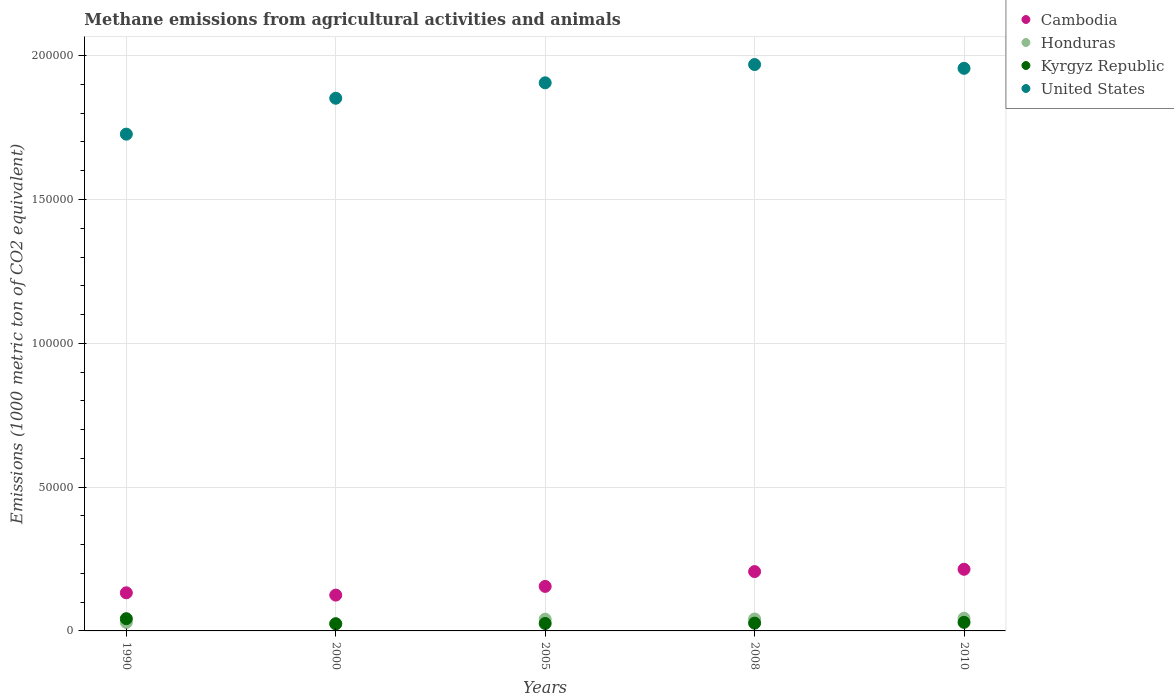How many different coloured dotlines are there?
Your answer should be compact. 4. Is the number of dotlines equal to the number of legend labels?
Your response must be concise. Yes. What is the amount of methane emitted in Honduras in 2010?
Your answer should be very brief. 4399.5. Across all years, what is the maximum amount of methane emitted in Honduras?
Your answer should be very brief. 4399.5. Across all years, what is the minimum amount of methane emitted in Kyrgyz Republic?
Provide a succinct answer. 2487.9. In which year was the amount of methane emitted in Honduras maximum?
Provide a short and direct response. 2010. In which year was the amount of methane emitted in Kyrgyz Republic minimum?
Keep it short and to the point. 2000. What is the total amount of methane emitted in Kyrgyz Republic in the graph?
Offer a very short reply. 1.50e+04. What is the difference between the amount of methane emitted in United States in 1990 and that in 2005?
Give a very brief answer. -1.78e+04. What is the difference between the amount of methane emitted in Kyrgyz Republic in 2000 and the amount of methane emitted in Honduras in 2008?
Your response must be concise. -1661.4. What is the average amount of methane emitted in United States per year?
Give a very brief answer. 1.88e+05. In the year 2005, what is the difference between the amount of methane emitted in Cambodia and amount of methane emitted in United States?
Provide a short and direct response. -1.75e+05. What is the ratio of the amount of methane emitted in United States in 1990 to that in 2005?
Ensure brevity in your answer.  0.91. What is the difference between the highest and the second highest amount of methane emitted in Kyrgyz Republic?
Your response must be concise. 1275.7. What is the difference between the highest and the lowest amount of methane emitted in Kyrgyz Republic?
Your answer should be very brief. 1766.7. In how many years, is the amount of methane emitted in Cambodia greater than the average amount of methane emitted in Cambodia taken over all years?
Offer a terse response. 2. Is it the case that in every year, the sum of the amount of methane emitted in Kyrgyz Republic and amount of methane emitted in Cambodia  is greater than the sum of amount of methane emitted in Honduras and amount of methane emitted in United States?
Your response must be concise. No. Is the amount of methane emitted in Kyrgyz Republic strictly greater than the amount of methane emitted in United States over the years?
Your answer should be compact. No. Is the amount of methane emitted in Cambodia strictly less than the amount of methane emitted in Honduras over the years?
Give a very brief answer. No. What is the difference between two consecutive major ticks on the Y-axis?
Offer a terse response. 5.00e+04. Are the values on the major ticks of Y-axis written in scientific E-notation?
Keep it short and to the point. No. Does the graph contain any zero values?
Your answer should be very brief. No. How are the legend labels stacked?
Give a very brief answer. Vertical. What is the title of the graph?
Give a very brief answer. Methane emissions from agricultural activities and animals. Does "Cabo Verde" appear as one of the legend labels in the graph?
Give a very brief answer. No. What is the label or title of the X-axis?
Your response must be concise. Years. What is the label or title of the Y-axis?
Ensure brevity in your answer.  Emissions (1000 metric ton of CO2 equivalent). What is the Emissions (1000 metric ton of CO2 equivalent) of Cambodia in 1990?
Offer a very short reply. 1.32e+04. What is the Emissions (1000 metric ton of CO2 equivalent) of Honduras in 1990?
Your answer should be compact. 2946.5. What is the Emissions (1000 metric ton of CO2 equivalent) of Kyrgyz Republic in 1990?
Give a very brief answer. 4254.6. What is the Emissions (1000 metric ton of CO2 equivalent) of United States in 1990?
Provide a succinct answer. 1.73e+05. What is the Emissions (1000 metric ton of CO2 equivalent) in Cambodia in 2000?
Offer a very short reply. 1.25e+04. What is the Emissions (1000 metric ton of CO2 equivalent) of Honduras in 2000?
Keep it short and to the point. 2470.9. What is the Emissions (1000 metric ton of CO2 equivalent) in Kyrgyz Republic in 2000?
Provide a succinct answer. 2487.9. What is the Emissions (1000 metric ton of CO2 equivalent) in United States in 2000?
Keep it short and to the point. 1.85e+05. What is the Emissions (1000 metric ton of CO2 equivalent) of Cambodia in 2005?
Provide a succinct answer. 1.55e+04. What is the Emissions (1000 metric ton of CO2 equivalent) in Honduras in 2005?
Provide a short and direct response. 4084.8. What is the Emissions (1000 metric ton of CO2 equivalent) of Kyrgyz Republic in 2005?
Offer a very short reply. 2595. What is the Emissions (1000 metric ton of CO2 equivalent) of United States in 2005?
Make the answer very short. 1.91e+05. What is the Emissions (1000 metric ton of CO2 equivalent) in Cambodia in 2008?
Provide a short and direct response. 2.06e+04. What is the Emissions (1000 metric ton of CO2 equivalent) in Honduras in 2008?
Your response must be concise. 4149.3. What is the Emissions (1000 metric ton of CO2 equivalent) of Kyrgyz Republic in 2008?
Provide a succinct answer. 2707.7. What is the Emissions (1000 metric ton of CO2 equivalent) in United States in 2008?
Your answer should be compact. 1.97e+05. What is the Emissions (1000 metric ton of CO2 equivalent) of Cambodia in 2010?
Your response must be concise. 2.14e+04. What is the Emissions (1000 metric ton of CO2 equivalent) in Honduras in 2010?
Ensure brevity in your answer.  4399.5. What is the Emissions (1000 metric ton of CO2 equivalent) in Kyrgyz Republic in 2010?
Offer a very short reply. 2978.9. What is the Emissions (1000 metric ton of CO2 equivalent) of United States in 2010?
Offer a terse response. 1.96e+05. Across all years, what is the maximum Emissions (1000 metric ton of CO2 equivalent) in Cambodia?
Your response must be concise. 2.14e+04. Across all years, what is the maximum Emissions (1000 metric ton of CO2 equivalent) in Honduras?
Give a very brief answer. 4399.5. Across all years, what is the maximum Emissions (1000 metric ton of CO2 equivalent) of Kyrgyz Republic?
Offer a very short reply. 4254.6. Across all years, what is the maximum Emissions (1000 metric ton of CO2 equivalent) of United States?
Give a very brief answer. 1.97e+05. Across all years, what is the minimum Emissions (1000 metric ton of CO2 equivalent) of Cambodia?
Ensure brevity in your answer.  1.25e+04. Across all years, what is the minimum Emissions (1000 metric ton of CO2 equivalent) of Honduras?
Keep it short and to the point. 2470.9. Across all years, what is the minimum Emissions (1000 metric ton of CO2 equivalent) of Kyrgyz Republic?
Keep it short and to the point. 2487.9. Across all years, what is the minimum Emissions (1000 metric ton of CO2 equivalent) of United States?
Your answer should be compact. 1.73e+05. What is the total Emissions (1000 metric ton of CO2 equivalent) in Cambodia in the graph?
Provide a succinct answer. 8.32e+04. What is the total Emissions (1000 metric ton of CO2 equivalent) in Honduras in the graph?
Ensure brevity in your answer.  1.81e+04. What is the total Emissions (1000 metric ton of CO2 equivalent) in Kyrgyz Republic in the graph?
Offer a very short reply. 1.50e+04. What is the total Emissions (1000 metric ton of CO2 equivalent) of United States in the graph?
Offer a very short reply. 9.41e+05. What is the difference between the Emissions (1000 metric ton of CO2 equivalent) of Cambodia in 1990 and that in 2000?
Provide a succinct answer. 796.5. What is the difference between the Emissions (1000 metric ton of CO2 equivalent) in Honduras in 1990 and that in 2000?
Your answer should be compact. 475.6. What is the difference between the Emissions (1000 metric ton of CO2 equivalent) in Kyrgyz Republic in 1990 and that in 2000?
Your response must be concise. 1766.7. What is the difference between the Emissions (1000 metric ton of CO2 equivalent) in United States in 1990 and that in 2000?
Your answer should be very brief. -1.25e+04. What is the difference between the Emissions (1000 metric ton of CO2 equivalent) of Cambodia in 1990 and that in 2005?
Your answer should be compact. -2227.1. What is the difference between the Emissions (1000 metric ton of CO2 equivalent) of Honduras in 1990 and that in 2005?
Ensure brevity in your answer.  -1138.3. What is the difference between the Emissions (1000 metric ton of CO2 equivalent) of Kyrgyz Republic in 1990 and that in 2005?
Make the answer very short. 1659.6. What is the difference between the Emissions (1000 metric ton of CO2 equivalent) in United States in 1990 and that in 2005?
Your answer should be very brief. -1.78e+04. What is the difference between the Emissions (1000 metric ton of CO2 equivalent) of Cambodia in 1990 and that in 2008?
Your answer should be very brief. -7382.4. What is the difference between the Emissions (1000 metric ton of CO2 equivalent) of Honduras in 1990 and that in 2008?
Ensure brevity in your answer.  -1202.8. What is the difference between the Emissions (1000 metric ton of CO2 equivalent) of Kyrgyz Republic in 1990 and that in 2008?
Provide a succinct answer. 1546.9. What is the difference between the Emissions (1000 metric ton of CO2 equivalent) in United States in 1990 and that in 2008?
Provide a short and direct response. -2.42e+04. What is the difference between the Emissions (1000 metric ton of CO2 equivalent) in Cambodia in 1990 and that in 2010?
Your response must be concise. -8182.5. What is the difference between the Emissions (1000 metric ton of CO2 equivalent) of Honduras in 1990 and that in 2010?
Offer a terse response. -1453. What is the difference between the Emissions (1000 metric ton of CO2 equivalent) of Kyrgyz Republic in 1990 and that in 2010?
Give a very brief answer. 1275.7. What is the difference between the Emissions (1000 metric ton of CO2 equivalent) in United States in 1990 and that in 2010?
Give a very brief answer. -2.29e+04. What is the difference between the Emissions (1000 metric ton of CO2 equivalent) in Cambodia in 2000 and that in 2005?
Offer a terse response. -3023.6. What is the difference between the Emissions (1000 metric ton of CO2 equivalent) of Honduras in 2000 and that in 2005?
Provide a succinct answer. -1613.9. What is the difference between the Emissions (1000 metric ton of CO2 equivalent) of Kyrgyz Republic in 2000 and that in 2005?
Your answer should be very brief. -107.1. What is the difference between the Emissions (1000 metric ton of CO2 equivalent) of United States in 2000 and that in 2005?
Your answer should be compact. -5362.7. What is the difference between the Emissions (1000 metric ton of CO2 equivalent) of Cambodia in 2000 and that in 2008?
Your answer should be very brief. -8178.9. What is the difference between the Emissions (1000 metric ton of CO2 equivalent) in Honduras in 2000 and that in 2008?
Offer a terse response. -1678.4. What is the difference between the Emissions (1000 metric ton of CO2 equivalent) of Kyrgyz Republic in 2000 and that in 2008?
Ensure brevity in your answer.  -219.8. What is the difference between the Emissions (1000 metric ton of CO2 equivalent) in United States in 2000 and that in 2008?
Your answer should be very brief. -1.17e+04. What is the difference between the Emissions (1000 metric ton of CO2 equivalent) of Cambodia in 2000 and that in 2010?
Ensure brevity in your answer.  -8979. What is the difference between the Emissions (1000 metric ton of CO2 equivalent) of Honduras in 2000 and that in 2010?
Keep it short and to the point. -1928.6. What is the difference between the Emissions (1000 metric ton of CO2 equivalent) in Kyrgyz Republic in 2000 and that in 2010?
Keep it short and to the point. -491. What is the difference between the Emissions (1000 metric ton of CO2 equivalent) of United States in 2000 and that in 2010?
Offer a terse response. -1.04e+04. What is the difference between the Emissions (1000 metric ton of CO2 equivalent) of Cambodia in 2005 and that in 2008?
Make the answer very short. -5155.3. What is the difference between the Emissions (1000 metric ton of CO2 equivalent) of Honduras in 2005 and that in 2008?
Give a very brief answer. -64.5. What is the difference between the Emissions (1000 metric ton of CO2 equivalent) in Kyrgyz Republic in 2005 and that in 2008?
Provide a succinct answer. -112.7. What is the difference between the Emissions (1000 metric ton of CO2 equivalent) of United States in 2005 and that in 2008?
Give a very brief answer. -6353.6. What is the difference between the Emissions (1000 metric ton of CO2 equivalent) of Cambodia in 2005 and that in 2010?
Offer a terse response. -5955.4. What is the difference between the Emissions (1000 metric ton of CO2 equivalent) in Honduras in 2005 and that in 2010?
Provide a short and direct response. -314.7. What is the difference between the Emissions (1000 metric ton of CO2 equivalent) in Kyrgyz Republic in 2005 and that in 2010?
Offer a very short reply. -383.9. What is the difference between the Emissions (1000 metric ton of CO2 equivalent) of United States in 2005 and that in 2010?
Provide a short and direct response. -5038.6. What is the difference between the Emissions (1000 metric ton of CO2 equivalent) of Cambodia in 2008 and that in 2010?
Give a very brief answer. -800.1. What is the difference between the Emissions (1000 metric ton of CO2 equivalent) of Honduras in 2008 and that in 2010?
Your response must be concise. -250.2. What is the difference between the Emissions (1000 metric ton of CO2 equivalent) in Kyrgyz Republic in 2008 and that in 2010?
Offer a very short reply. -271.2. What is the difference between the Emissions (1000 metric ton of CO2 equivalent) of United States in 2008 and that in 2010?
Offer a very short reply. 1315. What is the difference between the Emissions (1000 metric ton of CO2 equivalent) of Cambodia in 1990 and the Emissions (1000 metric ton of CO2 equivalent) of Honduras in 2000?
Provide a short and direct response. 1.08e+04. What is the difference between the Emissions (1000 metric ton of CO2 equivalent) in Cambodia in 1990 and the Emissions (1000 metric ton of CO2 equivalent) in Kyrgyz Republic in 2000?
Give a very brief answer. 1.08e+04. What is the difference between the Emissions (1000 metric ton of CO2 equivalent) in Cambodia in 1990 and the Emissions (1000 metric ton of CO2 equivalent) in United States in 2000?
Keep it short and to the point. -1.72e+05. What is the difference between the Emissions (1000 metric ton of CO2 equivalent) in Honduras in 1990 and the Emissions (1000 metric ton of CO2 equivalent) in Kyrgyz Republic in 2000?
Offer a very short reply. 458.6. What is the difference between the Emissions (1000 metric ton of CO2 equivalent) of Honduras in 1990 and the Emissions (1000 metric ton of CO2 equivalent) of United States in 2000?
Give a very brief answer. -1.82e+05. What is the difference between the Emissions (1000 metric ton of CO2 equivalent) in Kyrgyz Republic in 1990 and the Emissions (1000 metric ton of CO2 equivalent) in United States in 2000?
Offer a terse response. -1.81e+05. What is the difference between the Emissions (1000 metric ton of CO2 equivalent) of Cambodia in 1990 and the Emissions (1000 metric ton of CO2 equivalent) of Honduras in 2005?
Make the answer very short. 9165. What is the difference between the Emissions (1000 metric ton of CO2 equivalent) in Cambodia in 1990 and the Emissions (1000 metric ton of CO2 equivalent) in Kyrgyz Republic in 2005?
Your response must be concise. 1.07e+04. What is the difference between the Emissions (1000 metric ton of CO2 equivalent) of Cambodia in 1990 and the Emissions (1000 metric ton of CO2 equivalent) of United States in 2005?
Give a very brief answer. -1.77e+05. What is the difference between the Emissions (1000 metric ton of CO2 equivalent) in Honduras in 1990 and the Emissions (1000 metric ton of CO2 equivalent) in Kyrgyz Republic in 2005?
Your answer should be very brief. 351.5. What is the difference between the Emissions (1000 metric ton of CO2 equivalent) of Honduras in 1990 and the Emissions (1000 metric ton of CO2 equivalent) of United States in 2005?
Provide a short and direct response. -1.88e+05. What is the difference between the Emissions (1000 metric ton of CO2 equivalent) of Kyrgyz Republic in 1990 and the Emissions (1000 metric ton of CO2 equivalent) of United States in 2005?
Ensure brevity in your answer.  -1.86e+05. What is the difference between the Emissions (1000 metric ton of CO2 equivalent) in Cambodia in 1990 and the Emissions (1000 metric ton of CO2 equivalent) in Honduras in 2008?
Your response must be concise. 9100.5. What is the difference between the Emissions (1000 metric ton of CO2 equivalent) in Cambodia in 1990 and the Emissions (1000 metric ton of CO2 equivalent) in Kyrgyz Republic in 2008?
Offer a terse response. 1.05e+04. What is the difference between the Emissions (1000 metric ton of CO2 equivalent) in Cambodia in 1990 and the Emissions (1000 metric ton of CO2 equivalent) in United States in 2008?
Provide a succinct answer. -1.84e+05. What is the difference between the Emissions (1000 metric ton of CO2 equivalent) of Honduras in 1990 and the Emissions (1000 metric ton of CO2 equivalent) of Kyrgyz Republic in 2008?
Offer a terse response. 238.8. What is the difference between the Emissions (1000 metric ton of CO2 equivalent) of Honduras in 1990 and the Emissions (1000 metric ton of CO2 equivalent) of United States in 2008?
Provide a short and direct response. -1.94e+05. What is the difference between the Emissions (1000 metric ton of CO2 equivalent) in Kyrgyz Republic in 1990 and the Emissions (1000 metric ton of CO2 equivalent) in United States in 2008?
Keep it short and to the point. -1.93e+05. What is the difference between the Emissions (1000 metric ton of CO2 equivalent) in Cambodia in 1990 and the Emissions (1000 metric ton of CO2 equivalent) in Honduras in 2010?
Ensure brevity in your answer.  8850.3. What is the difference between the Emissions (1000 metric ton of CO2 equivalent) of Cambodia in 1990 and the Emissions (1000 metric ton of CO2 equivalent) of Kyrgyz Republic in 2010?
Ensure brevity in your answer.  1.03e+04. What is the difference between the Emissions (1000 metric ton of CO2 equivalent) of Cambodia in 1990 and the Emissions (1000 metric ton of CO2 equivalent) of United States in 2010?
Keep it short and to the point. -1.82e+05. What is the difference between the Emissions (1000 metric ton of CO2 equivalent) of Honduras in 1990 and the Emissions (1000 metric ton of CO2 equivalent) of Kyrgyz Republic in 2010?
Offer a very short reply. -32.4. What is the difference between the Emissions (1000 metric ton of CO2 equivalent) in Honduras in 1990 and the Emissions (1000 metric ton of CO2 equivalent) in United States in 2010?
Make the answer very short. -1.93e+05. What is the difference between the Emissions (1000 metric ton of CO2 equivalent) in Kyrgyz Republic in 1990 and the Emissions (1000 metric ton of CO2 equivalent) in United States in 2010?
Give a very brief answer. -1.91e+05. What is the difference between the Emissions (1000 metric ton of CO2 equivalent) of Cambodia in 2000 and the Emissions (1000 metric ton of CO2 equivalent) of Honduras in 2005?
Make the answer very short. 8368.5. What is the difference between the Emissions (1000 metric ton of CO2 equivalent) in Cambodia in 2000 and the Emissions (1000 metric ton of CO2 equivalent) in Kyrgyz Republic in 2005?
Your answer should be compact. 9858.3. What is the difference between the Emissions (1000 metric ton of CO2 equivalent) of Cambodia in 2000 and the Emissions (1000 metric ton of CO2 equivalent) of United States in 2005?
Provide a succinct answer. -1.78e+05. What is the difference between the Emissions (1000 metric ton of CO2 equivalent) in Honduras in 2000 and the Emissions (1000 metric ton of CO2 equivalent) in Kyrgyz Republic in 2005?
Offer a terse response. -124.1. What is the difference between the Emissions (1000 metric ton of CO2 equivalent) of Honduras in 2000 and the Emissions (1000 metric ton of CO2 equivalent) of United States in 2005?
Offer a very short reply. -1.88e+05. What is the difference between the Emissions (1000 metric ton of CO2 equivalent) of Kyrgyz Republic in 2000 and the Emissions (1000 metric ton of CO2 equivalent) of United States in 2005?
Give a very brief answer. -1.88e+05. What is the difference between the Emissions (1000 metric ton of CO2 equivalent) in Cambodia in 2000 and the Emissions (1000 metric ton of CO2 equivalent) in Honduras in 2008?
Provide a short and direct response. 8304. What is the difference between the Emissions (1000 metric ton of CO2 equivalent) of Cambodia in 2000 and the Emissions (1000 metric ton of CO2 equivalent) of Kyrgyz Republic in 2008?
Ensure brevity in your answer.  9745.6. What is the difference between the Emissions (1000 metric ton of CO2 equivalent) in Cambodia in 2000 and the Emissions (1000 metric ton of CO2 equivalent) in United States in 2008?
Your answer should be compact. -1.84e+05. What is the difference between the Emissions (1000 metric ton of CO2 equivalent) of Honduras in 2000 and the Emissions (1000 metric ton of CO2 equivalent) of Kyrgyz Republic in 2008?
Offer a terse response. -236.8. What is the difference between the Emissions (1000 metric ton of CO2 equivalent) in Honduras in 2000 and the Emissions (1000 metric ton of CO2 equivalent) in United States in 2008?
Make the answer very short. -1.94e+05. What is the difference between the Emissions (1000 metric ton of CO2 equivalent) in Kyrgyz Republic in 2000 and the Emissions (1000 metric ton of CO2 equivalent) in United States in 2008?
Provide a short and direct response. -1.94e+05. What is the difference between the Emissions (1000 metric ton of CO2 equivalent) of Cambodia in 2000 and the Emissions (1000 metric ton of CO2 equivalent) of Honduras in 2010?
Give a very brief answer. 8053.8. What is the difference between the Emissions (1000 metric ton of CO2 equivalent) in Cambodia in 2000 and the Emissions (1000 metric ton of CO2 equivalent) in Kyrgyz Republic in 2010?
Give a very brief answer. 9474.4. What is the difference between the Emissions (1000 metric ton of CO2 equivalent) of Cambodia in 2000 and the Emissions (1000 metric ton of CO2 equivalent) of United States in 2010?
Make the answer very short. -1.83e+05. What is the difference between the Emissions (1000 metric ton of CO2 equivalent) of Honduras in 2000 and the Emissions (1000 metric ton of CO2 equivalent) of Kyrgyz Republic in 2010?
Give a very brief answer. -508. What is the difference between the Emissions (1000 metric ton of CO2 equivalent) in Honduras in 2000 and the Emissions (1000 metric ton of CO2 equivalent) in United States in 2010?
Keep it short and to the point. -1.93e+05. What is the difference between the Emissions (1000 metric ton of CO2 equivalent) in Kyrgyz Republic in 2000 and the Emissions (1000 metric ton of CO2 equivalent) in United States in 2010?
Your answer should be very brief. -1.93e+05. What is the difference between the Emissions (1000 metric ton of CO2 equivalent) in Cambodia in 2005 and the Emissions (1000 metric ton of CO2 equivalent) in Honduras in 2008?
Offer a terse response. 1.13e+04. What is the difference between the Emissions (1000 metric ton of CO2 equivalent) of Cambodia in 2005 and the Emissions (1000 metric ton of CO2 equivalent) of Kyrgyz Republic in 2008?
Your response must be concise. 1.28e+04. What is the difference between the Emissions (1000 metric ton of CO2 equivalent) of Cambodia in 2005 and the Emissions (1000 metric ton of CO2 equivalent) of United States in 2008?
Your answer should be very brief. -1.81e+05. What is the difference between the Emissions (1000 metric ton of CO2 equivalent) of Honduras in 2005 and the Emissions (1000 metric ton of CO2 equivalent) of Kyrgyz Republic in 2008?
Make the answer very short. 1377.1. What is the difference between the Emissions (1000 metric ton of CO2 equivalent) in Honduras in 2005 and the Emissions (1000 metric ton of CO2 equivalent) in United States in 2008?
Offer a very short reply. -1.93e+05. What is the difference between the Emissions (1000 metric ton of CO2 equivalent) in Kyrgyz Republic in 2005 and the Emissions (1000 metric ton of CO2 equivalent) in United States in 2008?
Offer a very short reply. -1.94e+05. What is the difference between the Emissions (1000 metric ton of CO2 equivalent) of Cambodia in 2005 and the Emissions (1000 metric ton of CO2 equivalent) of Honduras in 2010?
Provide a short and direct response. 1.11e+04. What is the difference between the Emissions (1000 metric ton of CO2 equivalent) of Cambodia in 2005 and the Emissions (1000 metric ton of CO2 equivalent) of Kyrgyz Republic in 2010?
Offer a terse response. 1.25e+04. What is the difference between the Emissions (1000 metric ton of CO2 equivalent) in Cambodia in 2005 and the Emissions (1000 metric ton of CO2 equivalent) in United States in 2010?
Your answer should be compact. -1.80e+05. What is the difference between the Emissions (1000 metric ton of CO2 equivalent) in Honduras in 2005 and the Emissions (1000 metric ton of CO2 equivalent) in Kyrgyz Republic in 2010?
Provide a succinct answer. 1105.9. What is the difference between the Emissions (1000 metric ton of CO2 equivalent) of Honduras in 2005 and the Emissions (1000 metric ton of CO2 equivalent) of United States in 2010?
Provide a succinct answer. -1.92e+05. What is the difference between the Emissions (1000 metric ton of CO2 equivalent) in Kyrgyz Republic in 2005 and the Emissions (1000 metric ton of CO2 equivalent) in United States in 2010?
Your answer should be very brief. -1.93e+05. What is the difference between the Emissions (1000 metric ton of CO2 equivalent) in Cambodia in 2008 and the Emissions (1000 metric ton of CO2 equivalent) in Honduras in 2010?
Your answer should be compact. 1.62e+04. What is the difference between the Emissions (1000 metric ton of CO2 equivalent) in Cambodia in 2008 and the Emissions (1000 metric ton of CO2 equivalent) in Kyrgyz Republic in 2010?
Your response must be concise. 1.77e+04. What is the difference between the Emissions (1000 metric ton of CO2 equivalent) of Cambodia in 2008 and the Emissions (1000 metric ton of CO2 equivalent) of United States in 2010?
Your response must be concise. -1.75e+05. What is the difference between the Emissions (1000 metric ton of CO2 equivalent) of Honduras in 2008 and the Emissions (1000 metric ton of CO2 equivalent) of Kyrgyz Republic in 2010?
Your answer should be compact. 1170.4. What is the difference between the Emissions (1000 metric ton of CO2 equivalent) of Honduras in 2008 and the Emissions (1000 metric ton of CO2 equivalent) of United States in 2010?
Make the answer very short. -1.91e+05. What is the difference between the Emissions (1000 metric ton of CO2 equivalent) of Kyrgyz Republic in 2008 and the Emissions (1000 metric ton of CO2 equivalent) of United States in 2010?
Provide a short and direct response. -1.93e+05. What is the average Emissions (1000 metric ton of CO2 equivalent) of Cambodia per year?
Give a very brief answer. 1.66e+04. What is the average Emissions (1000 metric ton of CO2 equivalent) in Honduras per year?
Offer a terse response. 3610.2. What is the average Emissions (1000 metric ton of CO2 equivalent) of Kyrgyz Republic per year?
Provide a succinct answer. 3004.82. What is the average Emissions (1000 metric ton of CO2 equivalent) in United States per year?
Keep it short and to the point. 1.88e+05. In the year 1990, what is the difference between the Emissions (1000 metric ton of CO2 equivalent) in Cambodia and Emissions (1000 metric ton of CO2 equivalent) in Honduras?
Your answer should be very brief. 1.03e+04. In the year 1990, what is the difference between the Emissions (1000 metric ton of CO2 equivalent) of Cambodia and Emissions (1000 metric ton of CO2 equivalent) of Kyrgyz Republic?
Provide a short and direct response. 8995.2. In the year 1990, what is the difference between the Emissions (1000 metric ton of CO2 equivalent) in Cambodia and Emissions (1000 metric ton of CO2 equivalent) in United States?
Offer a terse response. -1.59e+05. In the year 1990, what is the difference between the Emissions (1000 metric ton of CO2 equivalent) in Honduras and Emissions (1000 metric ton of CO2 equivalent) in Kyrgyz Republic?
Offer a terse response. -1308.1. In the year 1990, what is the difference between the Emissions (1000 metric ton of CO2 equivalent) in Honduras and Emissions (1000 metric ton of CO2 equivalent) in United States?
Your answer should be compact. -1.70e+05. In the year 1990, what is the difference between the Emissions (1000 metric ton of CO2 equivalent) in Kyrgyz Republic and Emissions (1000 metric ton of CO2 equivalent) in United States?
Your response must be concise. -1.68e+05. In the year 2000, what is the difference between the Emissions (1000 metric ton of CO2 equivalent) in Cambodia and Emissions (1000 metric ton of CO2 equivalent) in Honduras?
Your response must be concise. 9982.4. In the year 2000, what is the difference between the Emissions (1000 metric ton of CO2 equivalent) in Cambodia and Emissions (1000 metric ton of CO2 equivalent) in Kyrgyz Republic?
Make the answer very short. 9965.4. In the year 2000, what is the difference between the Emissions (1000 metric ton of CO2 equivalent) in Cambodia and Emissions (1000 metric ton of CO2 equivalent) in United States?
Offer a terse response. -1.73e+05. In the year 2000, what is the difference between the Emissions (1000 metric ton of CO2 equivalent) of Honduras and Emissions (1000 metric ton of CO2 equivalent) of United States?
Ensure brevity in your answer.  -1.83e+05. In the year 2000, what is the difference between the Emissions (1000 metric ton of CO2 equivalent) of Kyrgyz Republic and Emissions (1000 metric ton of CO2 equivalent) of United States?
Ensure brevity in your answer.  -1.83e+05. In the year 2005, what is the difference between the Emissions (1000 metric ton of CO2 equivalent) of Cambodia and Emissions (1000 metric ton of CO2 equivalent) of Honduras?
Keep it short and to the point. 1.14e+04. In the year 2005, what is the difference between the Emissions (1000 metric ton of CO2 equivalent) of Cambodia and Emissions (1000 metric ton of CO2 equivalent) of Kyrgyz Republic?
Your answer should be compact. 1.29e+04. In the year 2005, what is the difference between the Emissions (1000 metric ton of CO2 equivalent) in Cambodia and Emissions (1000 metric ton of CO2 equivalent) in United States?
Offer a very short reply. -1.75e+05. In the year 2005, what is the difference between the Emissions (1000 metric ton of CO2 equivalent) in Honduras and Emissions (1000 metric ton of CO2 equivalent) in Kyrgyz Republic?
Give a very brief answer. 1489.8. In the year 2005, what is the difference between the Emissions (1000 metric ton of CO2 equivalent) of Honduras and Emissions (1000 metric ton of CO2 equivalent) of United States?
Keep it short and to the point. -1.86e+05. In the year 2005, what is the difference between the Emissions (1000 metric ton of CO2 equivalent) in Kyrgyz Republic and Emissions (1000 metric ton of CO2 equivalent) in United States?
Give a very brief answer. -1.88e+05. In the year 2008, what is the difference between the Emissions (1000 metric ton of CO2 equivalent) of Cambodia and Emissions (1000 metric ton of CO2 equivalent) of Honduras?
Offer a very short reply. 1.65e+04. In the year 2008, what is the difference between the Emissions (1000 metric ton of CO2 equivalent) of Cambodia and Emissions (1000 metric ton of CO2 equivalent) of Kyrgyz Republic?
Make the answer very short. 1.79e+04. In the year 2008, what is the difference between the Emissions (1000 metric ton of CO2 equivalent) in Cambodia and Emissions (1000 metric ton of CO2 equivalent) in United States?
Offer a terse response. -1.76e+05. In the year 2008, what is the difference between the Emissions (1000 metric ton of CO2 equivalent) of Honduras and Emissions (1000 metric ton of CO2 equivalent) of Kyrgyz Republic?
Provide a short and direct response. 1441.6. In the year 2008, what is the difference between the Emissions (1000 metric ton of CO2 equivalent) of Honduras and Emissions (1000 metric ton of CO2 equivalent) of United States?
Provide a succinct answer. -1.93e+05. In the year 2008, what is the difference between the Emissions (1000 metric ton of CO2 equivalent) of Kyrgyz Republic and Emissions (1000 metric ton of CO2 equivalent) of United States?
Your answer should be compact. -1.94e+05. In the year 2010, what is the difference between the Emissions (1000 metric ton of CO2 equivalent) of Cambodia and Emissions (1000 metric ton of CO2 equivalent) of Honduras?
Provide a succinct answer. 1.70e+04. In the year 2010, what is the difference between the Emissions (1000 metric ton of CO2 equivalent) in Cambodia and Emissions (1000 metric ton of CO2 equivalent) in Kyrgyz Republic?
Give a very brief answer. 1.85e+04. In the year 2010, what is the difference between the Emissions (1000 metric ton of CO2 equivalent) in Cambodia and Emissions (1000 metric ton of CO2 equivalent) in United States?
Your response must be concise. -1.74e+05. In the year 2010, what is the difference between the Emissions (1000 metric ton of CO2 equivalent) of Honduras and Emissions (1000 metric ton of CO2 equivalent) of Kyrgyz Republic?
Your answer should be very brief. 1420.6. In the year 2010, what is the difference between the Emissions (1000 metric ton of CO2 equivalent) of Honduras and Emissions (1000 metric ton of CO2 equivalent) of United States?
Make the answer very short. -1.91e+05. In the year 2010, what is the difference between the Emissions (1000 metric ton of CO2 equivalent) in Kyrgyz Republic and Emissions (1000 metric ton of CO2 equivalent) in United States?
Your answer should be very brief. -1.93e+05. What is the ratio of the Emissions (1000 metric ton of CO2 equivalent) in Cambodia in 1990 to that in 2000?
Your response must be concise. 1.06. What is the ratio of the Emissions (1000 metric ton of CO2 equivalent) in Honduras in 1990 to that in 2000?
Make the answer very short. 1.19. What is the ratio of the Emissions (1000 metric ton of CO2 equivalent) of Kyrgyz Republic in 1990 to that in 2000?
Your answer should be very brief. 1.71. What is the ratio of the Emissions (1000 metric ton of CO2 equivalent) of United States in 1990 to that in 2000?
Provide a succinct answer. 0.93. What is the ratio of the Emissions (1000 metric ton of CO2 equivalent) in Cambodia in 1990 to that in 2005?
Keep it short and to the point. 0.86. What is the ratio of the Emissions (1000 metric ton of CO2 equivalent) of Honduras in 1990 to that in 2005?
Ensure brevity in your answer.  0.72. What is the ratio of the Emissions (1000 metric ton of CO2 equivalent) of Kyrgyz Republic in 1990 to that in 2005?
Provide a short and direct response. 1.64. What is the ratio of the Emissions (1000 metric ton of CO2 equivalent) in United States in 1990 to that in 2005?
Give a very brief answer. 0.91. What is the ratio of the Emissions (1000 metric ton of CO2 equivalent) of Cambodia in 1990 to that in 2008?
Your answer should be compact. 0.64. What is the ratio of the Emissions (1000 metric ton of CO2 equivalent) of Honduras in 1990 to that in 2008?
Your answer should be very brief. 0.71. What is the ratio of the Emissions (1000 metric ton of CO2 equivalent) in Kyrgyz Republic in 1990 to that in 2008?
Offer a very short reply. 1.57. What is the ratio of the Emissions (1000 metric ton of CO2 equivalent) of United States in 1990 to that in 2008?
Ensure brevity in your answer.  0.88. What is the ratio of the Emissions (1000 metric ton of CO2 equivalent) of Cambodia in 1990 to that in 2010?
Provide a short and direct response. 0.62. What is the ratio of the Emissions (1000 metric ton of CO2 equivalent) in Honduras in 1990 to that in 2010?
Keep it short and to the point. 0.67. What is the ratio of the Emissions (1000 metric ton of CO2 equivalent) in Kyrgyz Republic in 1990 to that in 2010?
Ensure brevity in your answer.  1.43. What is the ratio of the Emissions (1000 metric ton of CO2 equivalent) of United States in 1990 to that in 2010?
Offer a terse response. 0.88. What is the ratio of the Emissions (1000 metric ton of CO2 equivalent) of Cambodia in 2000 to that in 2005?
Give a very brief answer. 0.8. What is the ratio of the Emissions (1000 metric ton of CO2 equivalent) in Honduras in 2000 to that in 2005?
Offer a terse response. 0.6. What is the ratio of the Emissions (1000 metric ton of CO2 equivalent) in Kyrgyz Republic in 2000 to that in 2005?
Offer a very short reply. 0.96. What is the ratio of the Emissions (1000 metric ton of CO2 equivalent) of United States in 2000 to that in 2005?
Make the answer very short. 0.97. What is the ratio of the Emissions (1000 metric ton of CO2 equivalent) of Cambodia in 2000 to that in 2008?
Provide a succinct answer. 0.6. What is the ratio of the Emissions (1000 metric ton of CO2 equivalent) in Honduras in 2000 to that in 2008?
Your answer should be compact. 0.6. What is the ratio of the Emissions (1000 metric ton of CO2 equivalent) of Kyrgyz Republic in 2000 to that in 2008?
Offer a terse response. 0.92. What is the ratio of the Emissions (1000 metric ton of CO2 equivalent) in United States in 2000 to that in 2008?
Ensure brevity in your answer.  0.94. What is the ratio of the Emissions (1000 metric ton of CO2 equivalent) in Cambodia in 2000 to that in 2010?
Make the answer very short. 0.58. What is the ratio of the Emissions (1000 metric ton of CO2 equivalent) in Honduras in 2000 to that in 2010?
Provide a succinct answer. 0.56. What is the ratio of the Emissions (1000 metric ton of CO2 equivalent) in Kyrgyz Republic in 2000 to that in 2010?
Your answer should be very brief. 0.84. What is the ratio of the Emissions (1000 metric ton of CO2 equivalent) in United States in 2000 to that in 2010?
Your answer should be compact. 0.95. What is the ratio of the Emissions (1000 metric ton of CO2 equivalent) of Cambodia in 2005 to that in 2008?
Provide a succinct answer. 0.75. What is the ratio of the Emissions (1000 metric ton of CO2 equivalent) in Honduras in 2005 to that in 2008?
Make the answer very short. 0.98. What is the ratio of the Emissions (1000 metric ton of CO2 equivalent) of Kyrgyz Republic in 2005 to that in 2008?
Provide a succinct answer. 0.96. What is the ratio of the Emissions (1000 metric ton of CO2 equivalent) in United States in 2005 to that in 2008?
Your answer should be compact. 0.97. What is the ratio of the Emissions (1000 metric ton of CO2 equivalent) of Cambodia in 2005 to that in 2010?
Your answer should be compact. 0.72. What is the ratio of the Emissions (1000 metric ton of CO2 equivalent) of Honduras in 2005 to that in 2010?
Your answer should be compact. 0.93. What is the ratio of the Emissions (1000 metric ton of CO2 equivalent) in Kyrgyz Republic in 2005 to that in 2010?
Provide a short and direct response. 0.87. What is the ratio of the Emissions (1000 metric ton of CO2 equivalent) of United States in 2005 to that in 2010?
Keep it short and to the point. 0.97. What is the ratio of the Emissions (1000 metric ton of CO2 equivalent) in Cambodia in 2008 to that in 2010?
Ensure brevity in your answer.  0.96. What is the ratio of the Emissions (1000 metric ton of CO2 equivalent) in Honduras in 2008 to that in 2010?
Make the answer very short. 0.94. What is the ratio of the Emissions (1000 metric ton of CO2 equivalent) in Kyrgyz Republic in 2008 to that in 2010?
Ensure brevity in your answer.  0.91. What is the ratio of the Emissions (1000 metric ton of CO2 equivalent) in United States in 2008 to that in 2010?
Provide a succinct answer. 1.01. What is the difference between the highest and the second highest Emissions (1000 metric ton of CO2 equivalent) of Cambodia?
Give a very brief answer. 800.1. What is the difference between the highest and the second highest Emissions (1000 metric ton of CO2 equivalent) of Honduras?
Your answer should be compact. 250.2. What is the difference between the highest and the second highest Emissions (1000 metric ton of CO2 equivalent) in Kyrgyz Republic?
Your answer should be very brief. 1275.7. What is the difference between the highest and the second highest Emissions (1000 metric ton of CO2 equivalent) in United States?
Provide a succinct answer. 1315. What is the difference between the highest and the lowest Emissions (1000 metric ton of CO2 equivalent) of Cambodia?
Make the answer very short. 8979. What is the difference between the highest and the lowest Emissions (1000 metric ton of CO2 equivalent) in Honduras?
Your answer should be very brief. 1928.6. What is the difference between the highest and the lowest Emissions (1000 metric ton of CO2 equivalent) of Kyrgyz Republic?
Make the answer very short. 1766.7. What is the difference between the highest and the lowest Emissions (1000 metric ton of CO2 equivalent) in United States?
Give a very brief answer. 2.42e+04. 